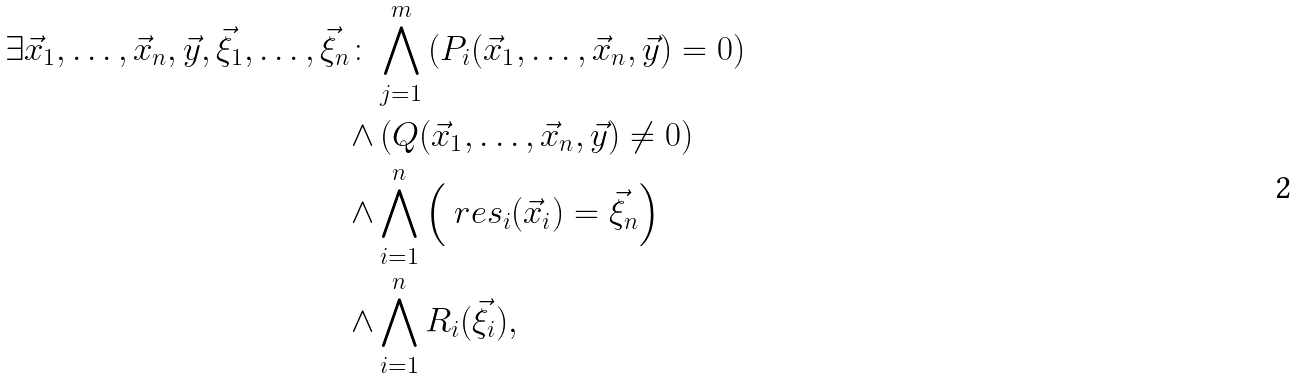Convert formula to latex. <formula><loc_0><loc_0><loc_500><loc_500>\exists \vec { x } _ { 1 } , \dots , \vec { x } _ { n } , \vec { y } , \vec { \xi } _ { 1 } , \dots , \vec { \xi } _ { n } \colon & \bigwedge _ { j = 1 } ^ { m } \left ( P _ { i } ( \vec { x } _ { 1 } , \dots , \vec { x } _ { n } , \vec { y } ) = 0 \right ) \\ \wedge & \left ( Q ( \vec { x } _ { 1 } , \dots , \vec { x } _ { n } , \vec { y } ) \ne 0 \right ) \\ \wedge & \bigwedge _ { i = 1 } ^ { n } \left ( \ r e s _ { i } ( \vec { x } _ { i } ) = \vec { \xi } _ { n } \right ) \\ \wedge & \bigwedge _ { i = 1 } ^ { n } R _ { i } ( \vec { \xi } _ { i } ) ,</formula> 